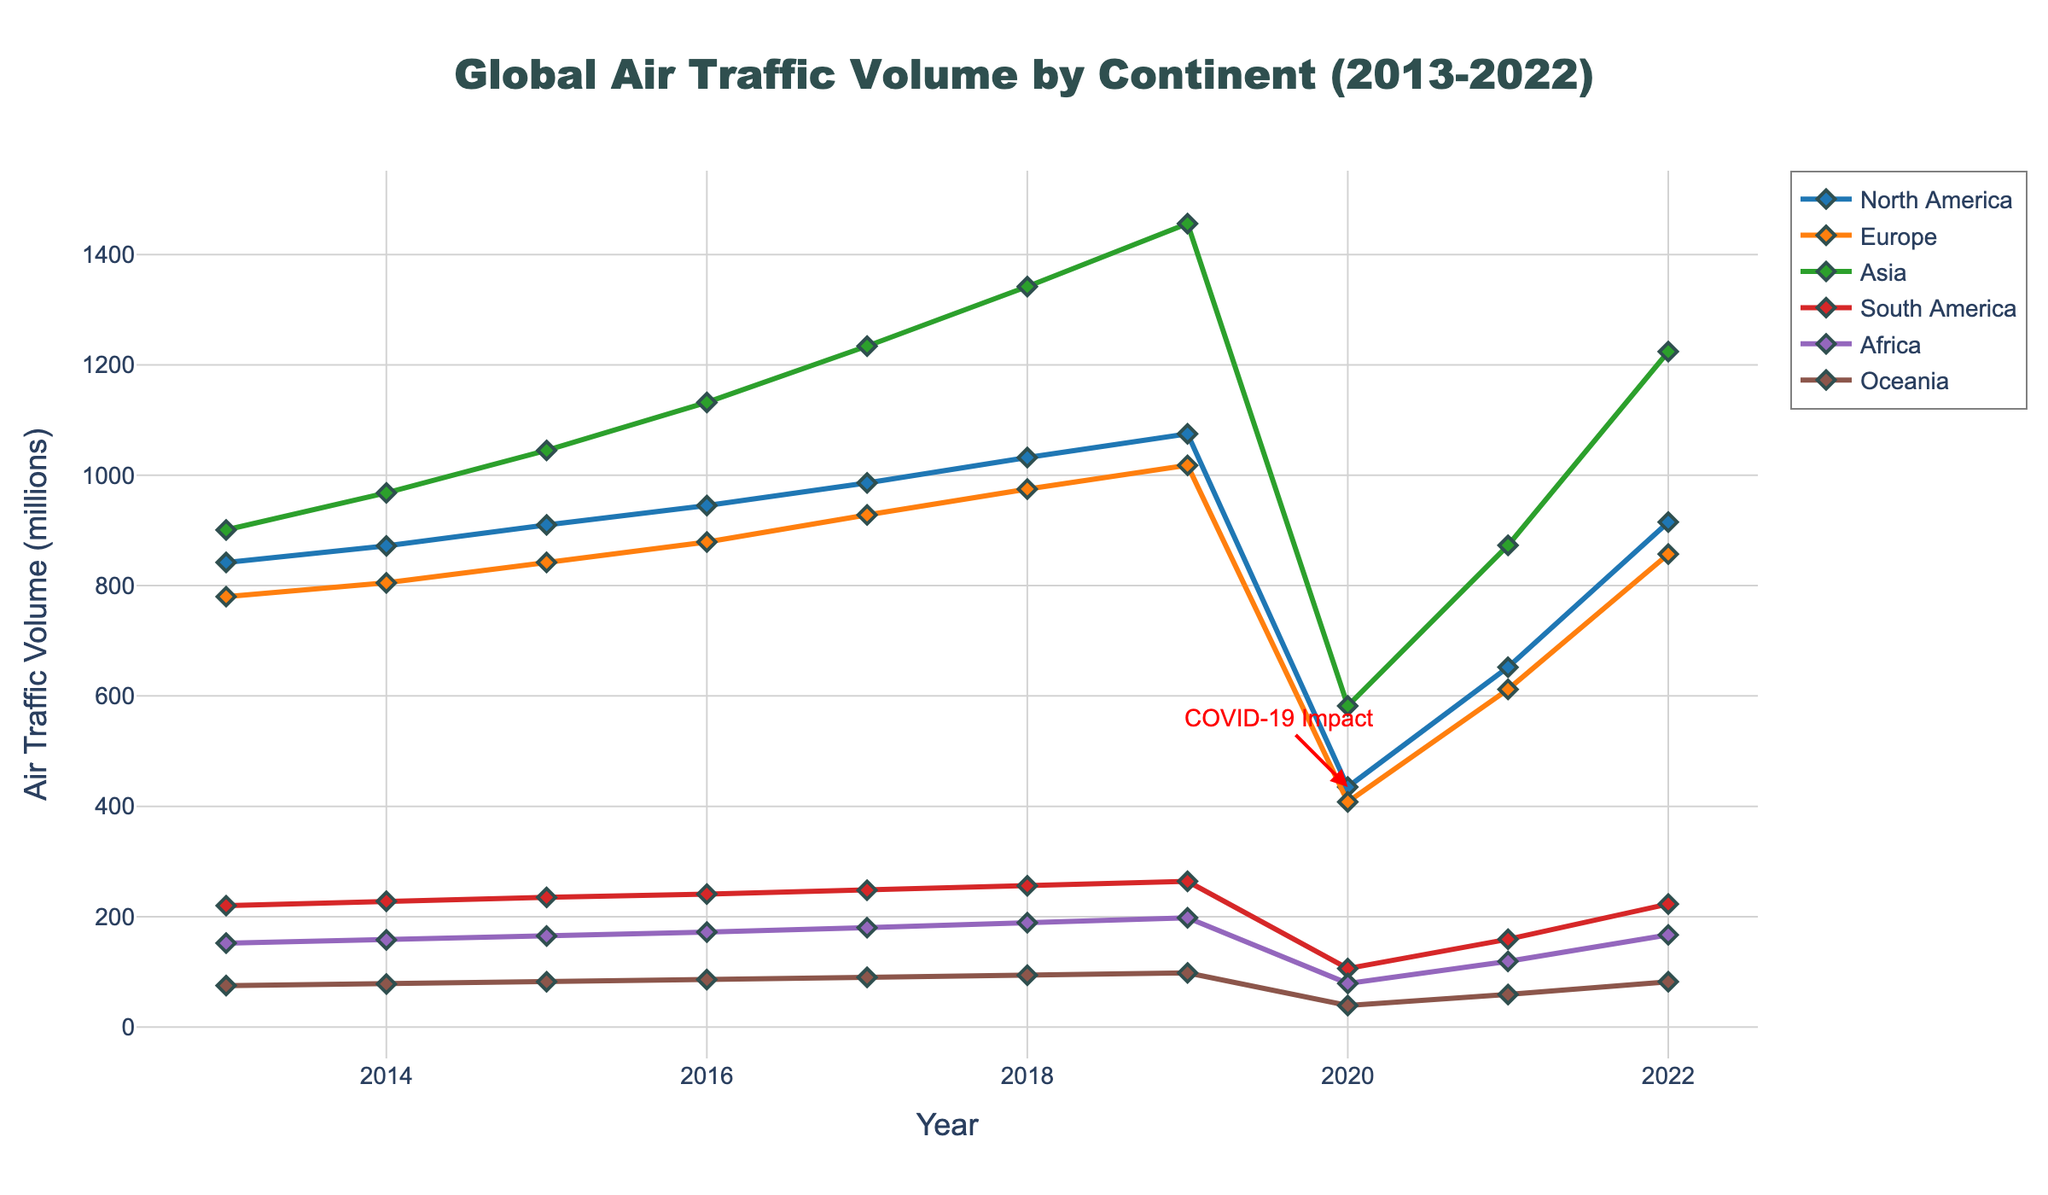How did air traffic volume in North America change from 2013 to 2022? In North America, the air traffic volume increased from 842 million in 2013 to 915 million in 2022, despite a significant drop in 2020 due to COVID-19. This shows an overall upward trend with a temporary dip in 2020.
Answer: Increased from 842 to 915 million Which continent had the highest air traffic volume in 2019? By comparing the data for 2019, Asia had the highest air traffic volume with 1456 million, followed by North America with 1075 million.
Answer: Asia How did the COVID-19 pandemic affect global air traffic volumes in 2020 compared to 2019? In 2019, global air traffic volumes were relatively high across all continents. However, in 2020, there was a noticeable decline in air traffic volumes, with North America, Europe, Asia, South America, Africa, and Oceania seeing drops to 435, 408, 582, 106, 79, and 39 million, respectively.
Answer: Significant decrease Are there any continents that show recovery in air traffic volume by 2022 after the decline in 2020? Comparing 2020 and 2022 data, multiple continents show recovery. For instance, North America's volume increased from 435 million in 2020 to 915 million in 2022, and Asia's volume increased from 582 million to 1224 million.
Answer: Yes, multiple continents Between 2013 and 2019, which continent experienced the fastest growth in air traffic volume? Analyzing the data from 2013 to 2019, Asia's traffic volume grew from 901 million to 1456 million, a difference of 555 million, which is the highest absolute increase among all continents.
Answer: Asia What was the air traffic volume difference between Europe and South America in 2015? In 2015, Europe had an air traffic volume of 842 million while South America had 235 million. The difference is 842 - 235 = 607 million.
Answer: 607 million In which year did Oceania see the lowest air traffic volume, and what was that volume? From the chart, Oceania's lowest air traffic volume was in 2020, with a volume of 39 million.
Answer: 2020, 39 million By how much did Africa’s air traffic volume decrease from 2019 to 2020? Africa’s volume was 198 million in 2019 and it decreased to 79 million in 2020. The difference is 198 - 79 = 119 million.
Answer: 119 million How did the air traffic volume in Europe change between 2016 and 2017? In Europe, the air traffic volume increased from 879 million in 2016 to 928 million in 2017, showing an increase of 928 - 879 = 49 million.
Answer: Increased by 49 million Which continent had the least air traffic volume in 2021? From the chart for 2021, Oceania had the least air traffic volume with 59 million.
Answer: Oceania 